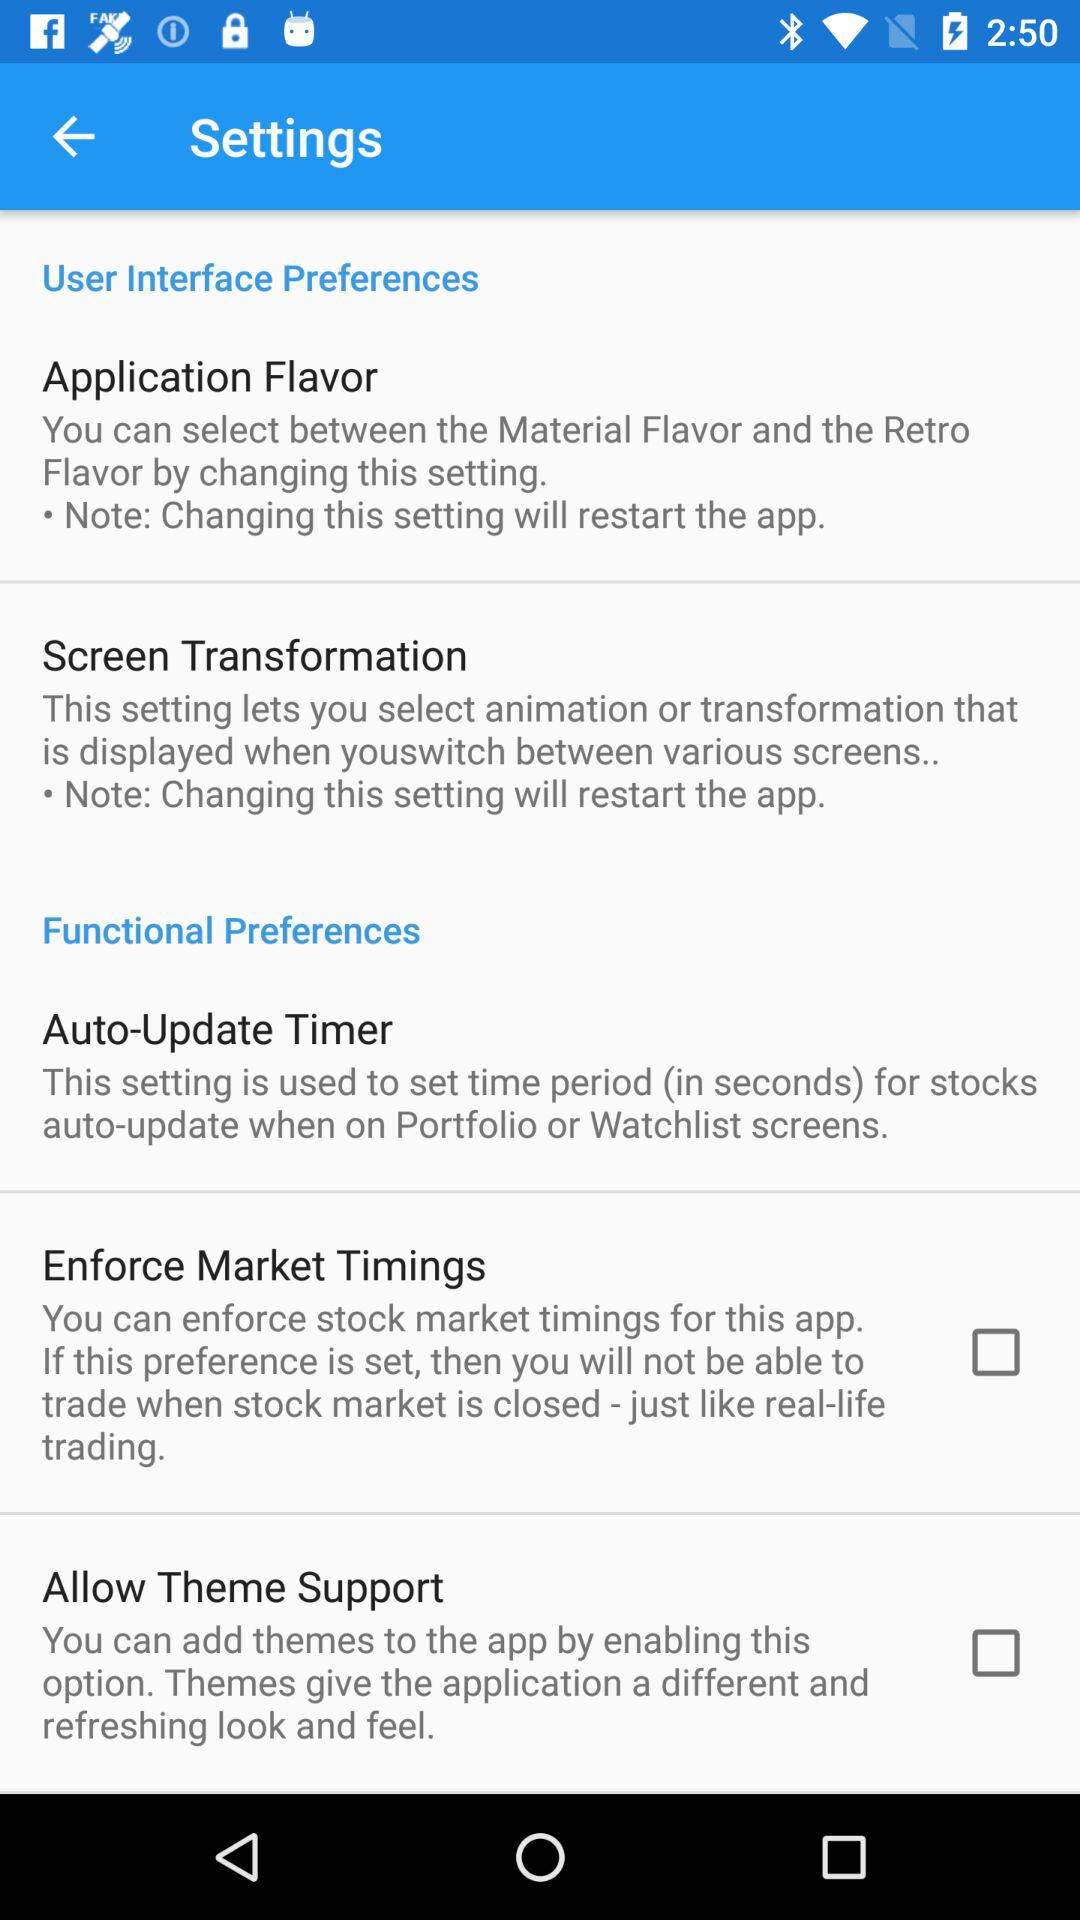What is the purpose of the auto-update timer? The purpose of the auto-update timer is to set the time period (in seconds) for stocks to auto-update when on the Portfolio or Watchlist screens. 